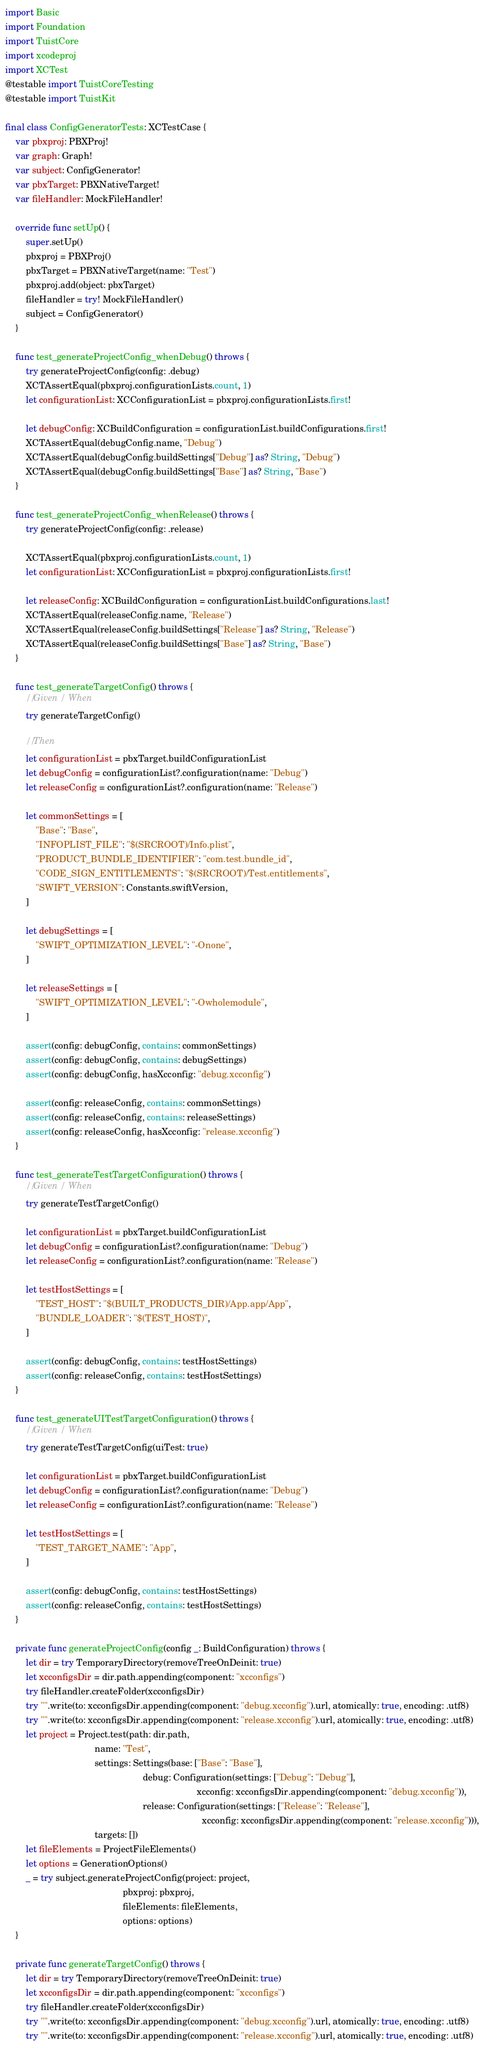Convert code to text. <code><loc_0><loc_0><loc_500><loc_500><_Swift_>import Basic
import Foundation
import TuistCore
import xcodeproj
import XCTest
@testable import TuistCoreTesting
@testable import TuistKit

final class ConfigGeneratorTests: XCTestCase {
    var pbxproj: PBXProj!
    var graph: Graph!
    var subject: ConfigGenerator!
    var pbxTarget: PBXNativeTarget!
    var fileHandler: MockFileHandler!

    override func setUp() {
        super.setUp()
        pbxproj = PBXProj()
        pbxTarget = PBXNativeTarget(name: "Test")
        pbxproj.add(object: pbxTarget)
        fileHandler = try! MockFileHandler()
        subject = ConfigGenerator()
    }

    func test_generateProjectConfig_whenDebug() throws {
        try generateProjectConfig(config: .debug)
        XCTAssertEqual(pbxproj.configurationLists.count, 1)
        let configurationList: XCConfigurationList = pbxproj.configurationLists.first!

        let debugConfig: XCBuildConfiguration = configurationList.buildConfigurations.first!
        XCTAssertEqual(debugConfig.name, "Debug")
        XCTAssertEqual(debugConfig.buildSettings["Debug"] as? String, "Debug")
        XCTAssertEqual(debugConfig.buildSettings["Base"] as? String, "Base")
    }

    func test_generateProjectConfig_whenRelease() throws {
        try generateProjectConfig(config: .release)

        XCTAssertEqual(pbxproj.configurationLists.count, 1)
        let configurationList: XCConfigurationList = pbxproj.configurationLists.first!

        let releaseConfig: XCBuildConfiguration = configurationList.buildConfigurations.last!
        XCTAssertEqual(releaseConfig.name, "Release")
        XCTAssertEqual(releaseConfig.buildSettings["Release"] as? String, "Release")
        XCTAssertEqual(releaseConfig.buildSettings["Base"] as? String, "Base")
    }

    func test_generateTargetConfig() throws {
        // Given / When
        try generateTargetConfig()

        // Then
        let configurationList = pbxTarget.buildConfigurationList
        let debugConfig = configurationList?.configuration(name: "Debug")
        let releaseConfig = configurationList?.configuration(name: "Release")

        let commonSettings = [
            "Base": "Base",
            "INFOPLIST_FILE": "$(SRCROOT)/Info.plist",
            "PRODUCT_BUNDLE_IDENTIFIER": "com.test.bundle_id",
            "CODE_SIGN_ENTITLEMENTS": "$(SRCROOT)/Test.entitlements",
            "SWIFT_VERSION": Constants.swiftVersion,
        ]

        let debugSettings = [
            "SWIFT_OPTIMIZATION_LEVEL": "-Onone",
        ]

        let releaseSettings = [
            "SWIFT_OPTIMIZATION_LEVEL": "-Owholemodule",
        ]

        assert(config: debugConfig, contains: commonSettings)
        assert(config: debugConfig, contains: debugSettings)
        assert(config: debugConfig, hasXcconfig: "debug.xcconfig")

        assert(config: releaseConfig, contains: commonSettings)
        assert(config: releaseConfig, contains: releaseSettings)
        assert(config: releaseConfig, hasXcconfig: "release.xcconfig")
    }

    func test_generateTestTargetConfiguration() throws {
        // Given / When
        try generateTestTargetConfig()

        let configurationList = pbxTarget.buildConfigurationList
        let debugConfig = configurationList?.configuration(name: "Debug")
        let releaseConfig = configurationList?.configuration(name: "Release")

        let testHostSettings = [
            "TEST_HOST": "$(BUILT_PRODUCTS_DIR)/App.app/App",
            "BUNDLE_LOADER": "$(TEST_HOST)",
        ]

        assert(config: debugConfig, contains: testHostSettings)
        assert(config: releaseConfig, contains: testHostSettings)
    }

    func test_generateUITestTargetConfiguration() throws {
        // Given / When
        try generateTestTargetConfig(uiTest: true)

        let configurationList = pbxTarget.buildConfigurationList
        let debugConfig = configurationList?.configuration(name: "Debug")
        let releaseConfig = configurationList?.configuration(name: "Release")

        let testHostSettings = [
            "TEST_TARGET_NAME": "App",
        ]

        assert(config: debugConfig, contains: testHostSettings)
        assert(config: releaseConfig, contains: testHostSettings)
    }

    private func generateProjectConfig(config _: BuildConfiguration) throws {
        let dir = try TemporaryDirectory(removeTreeOnDeinit: true)
        let xcconfigsDir = dir.path.appending(component: "xcconfigs")
        try fileHandler.createFolder(xcconfigsDir)
        try "".write(to: xcconfigsDir.appending(component: "debug.xcconfig").url, atomically: true, encoding: .utf8)
        try "".write(to: xcconfigsDir.appending(component: "release.xcconfig").url, atomically: true, encoding: .utf8)
        let project = Project.test(path: dir.path,
                                   name: "Test",
                                   settings: Settings(base: ["Base": "Base"],
                                                      debug: Configuration(settings: ["Debug": "Debug"],
                                                                           xcconfig: xcconfigsDir.appending(component: "debug.xcconfig")),
                                                      release: Configuration(settings: ["Release": "Release"],
                                                                             xcconfig: xcconfigsDir.appending(component: "release.xcconfig"))),
                                   targets: [])
        let fileElements = ProjectFileElements()
        let options = GenerationOptions()
        _ = try subject.generateProjectConfig(project: project,
                                              pbxproj: pbxproj,
                                              fileElements: fileElements,
                                              options: options)
    }

    private func generateTargetConfig() throws {
        let dir = try TemporaryDirectory(removeTreeOnDeinit: true)
        let xcconfigsDir = dir.path.appending(component: "xcconfigs")
        try fileHandler.createFolder(xcconfigsDir)
        try "".write(to: xcconfigsDir.appending(component: "debug.xcconfig").url, atomically: true, encoding: .utf8)
        try "".write(to: xcconfigsDir.appending(component: "release.xcconfig").url, atomically: true, encoding: .utf8)</code> 